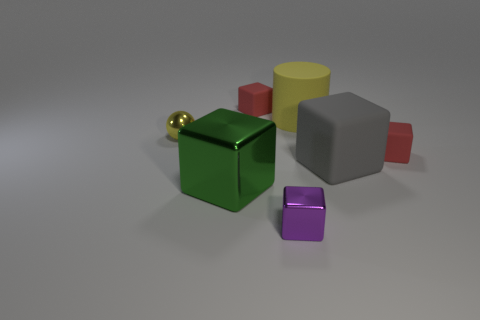Subtract all blocks. How many objects are left? 2 Add 2 gray matte blocks. How many objects exist? 9 Subtract all large rubber blocks. How many blocks are left? 4 Subtract 0 red spheres. How many objects are left? 7 Subtract 3 blocks. How many blocks are left? 2 Subtract all green cylinders. Subtract all blue cubes. How many cylinders are left? 1 Subtract all cyan balls. How many purple blocks are left? 1 Subtract all cylinders. Subtract all large red balls. How many objects are left? 6 Add 3 green metal objects. How many green metal objects are left? 4 Add 5 green blocks. How many green blocks exist? 6 